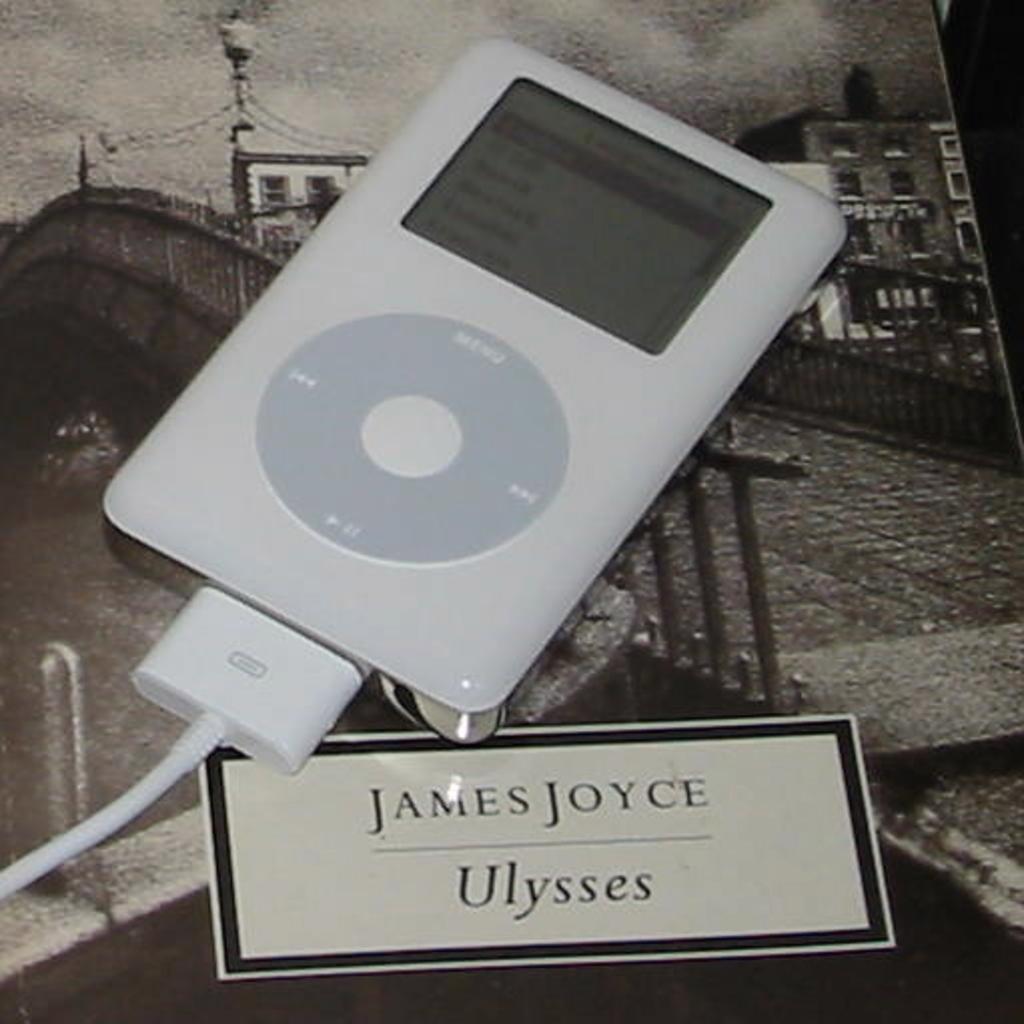Can you describe this image briefly? Here we can see an iPod, cable, and a card. In the background we can see picture of a building, board, fence, and a light. 